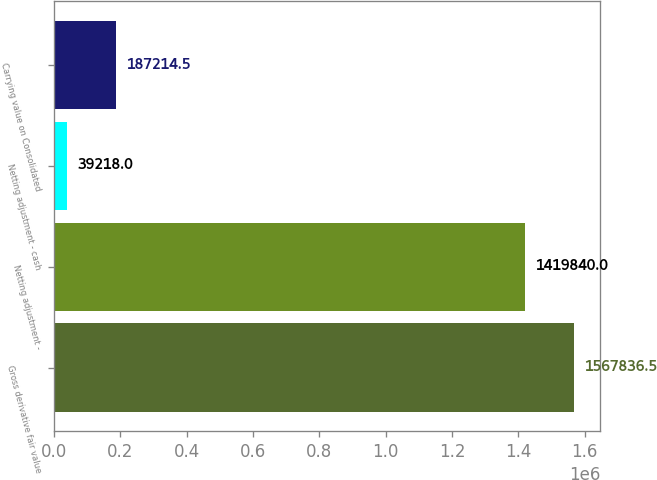Convert chart to OTSL. <chart><loc_0><loc_0><loc_500><loc_500><bar_chart><fcel>Gross derivative fair value<fcel>Netting adjustment -<fcel>Netting adjustment - cash<fcel>Carrying value on Consolidated<nl><fcel>1.56784e+06<fcel>1.41984e+06<fcel>39218<fcel>187214<nl></chart> 